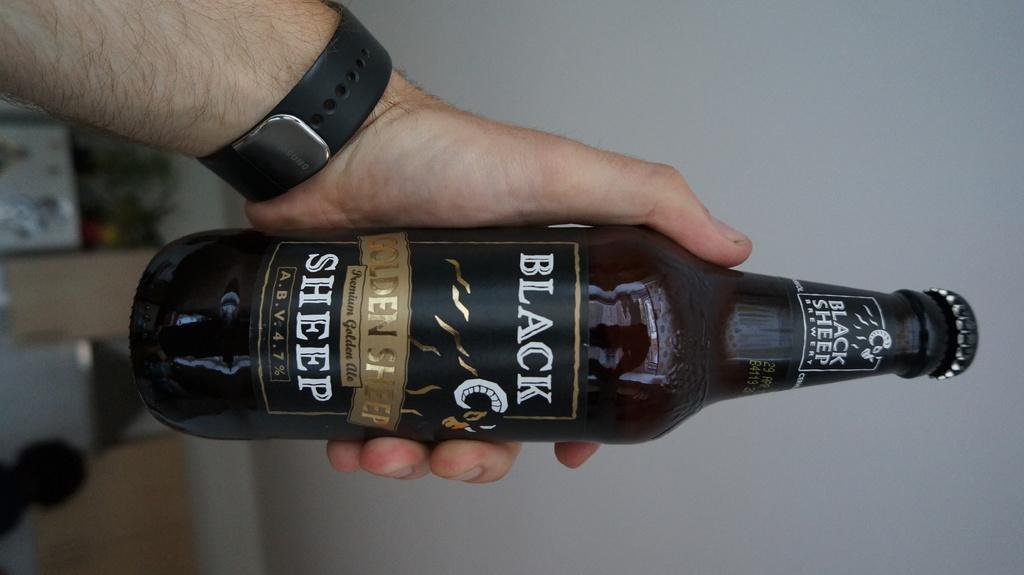What color is the sheep?
Keep it short and to the point. Black. What is the percent alcohol listed on the bottle?
Your answer should be compact. 4.7%. 